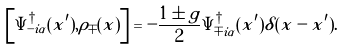Convert formula to latex. <formula><loc_0><loc_0><loc_500><loc_500>\left [ \Psi ^ { \dagger } _ { - i \alpha } ( x ^ { \prime } ) , \rho _ { \mp } ( x ) \right ] = - \frac { 1 \pm g } { 2 } \Psi ^ { \dagger } _ { \mp i \alpha } ( x ^ { \prime } ) \delta ( x - x ^ { \prime } ) .</formula> 